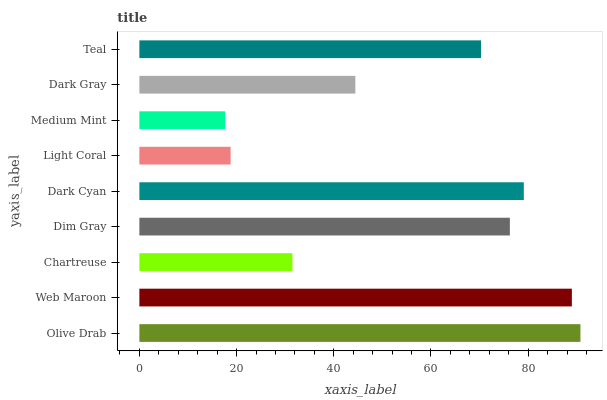Is Medium Mint the minimum?
Answer yes or no. Yes. Is Olive Drab the maximum?
Answer yes or no. Yes. Is Web Maroon the minimum?
Answer yes or no. No. Is Web Maroon the maximum?
Answer yes or no. No. Is Olive Drab greater than Web Maroon?
Answer yes or no. Yes. Is Web Maroon less than Olive Drab?
Answer yes or no. Yes. Is Web Maroon greater than Olive Drab?
Answer yes or no. No. Is Olive Drab less than Web Maroon?
Answer yes or no. No. Is Teal the high median?
Answer yes or no. Yes. Is Teal the low median?
Answer yes or no. Yes. Is Medium Mint the high median?
Answer yes or no. No. Is Medium Mint the low median?
Answer yes or no. No. 